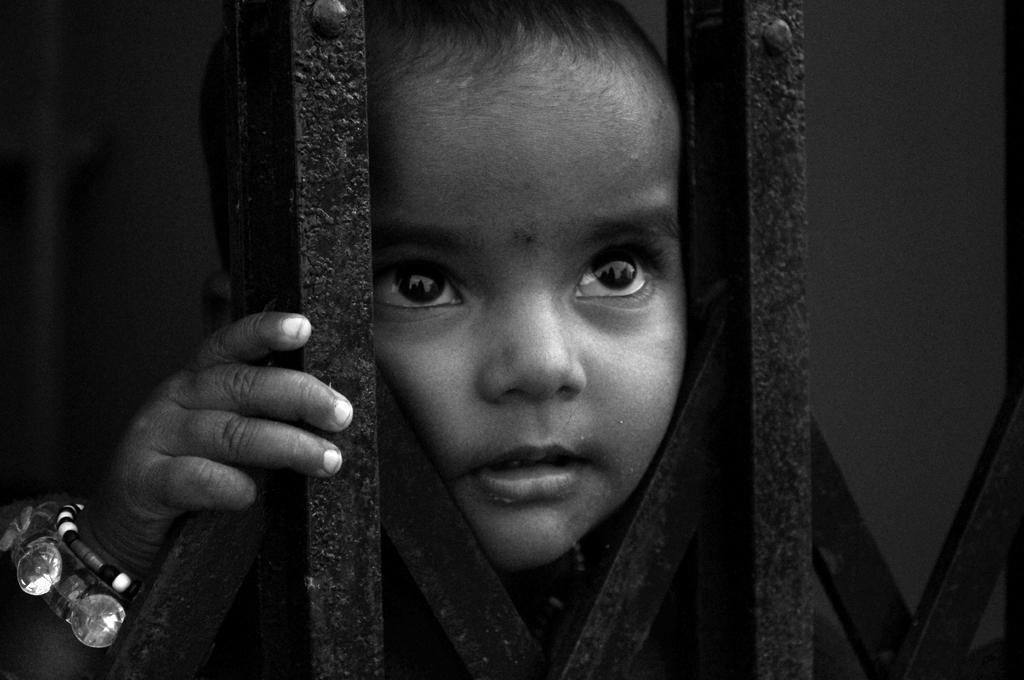What is the main subject of the picture? The main subject of the picture is a kid. What is the color scheme of the picture? The picture is black and white. What can be seen in the background of the picture? There are grills visible in the picture. What type of bird can be seen flying in the picture? There is no bird visible in the picture; it is a black and white image of a kid and grills. 